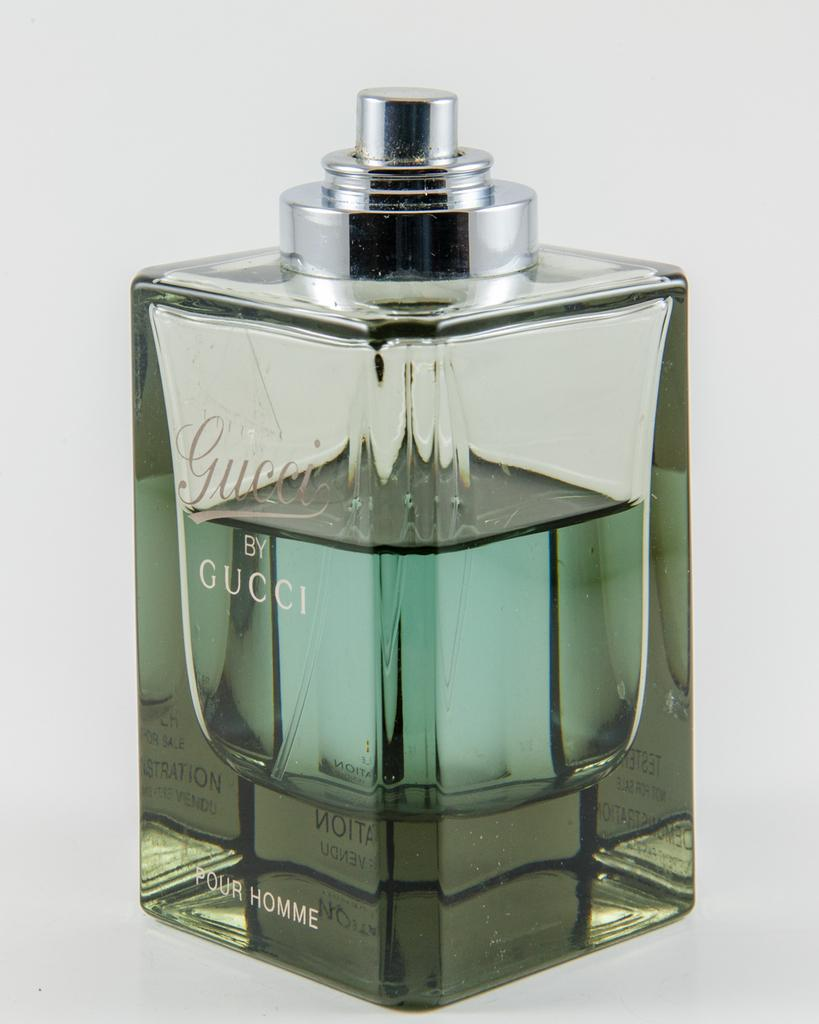<image>
Render a clear and concise summary of the photo. A bottle of Gucci by Gucci cologne sits on a table. 